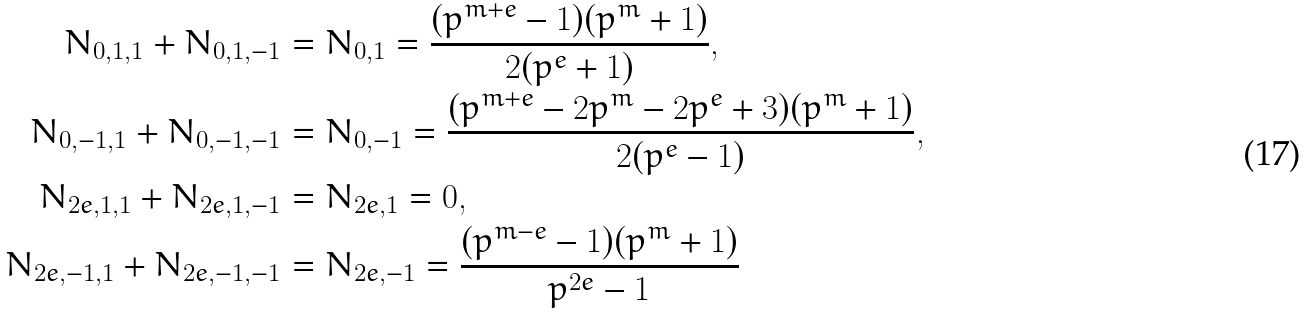<formula> <loc_0><loc_0><loc_500><loc_500>N _ { 0 , 1 , 1 } + N _ { 0 , 1 , - 1 } & = N _ { 0 , 1 } = \frac { ( p ^ { m + e } - 1 ) ( p ^ { m } + 1 ) } { 2 ( p ^ { e } + 1 ) } , \\ N _ { 0 , - 1 , 1 } + N _ { 0 , - 1 , - 1 } & = N _ { 0 , - 1 } = \frac { ( p ^ { m + e } - 2 p ^ { m } - 2 p ^ { e } + 3 ) ( p ^ { m } + 1 ) } { 2 ( p ^ { e } - 1 ) } , \\ N _ { 2 e , 1 , 1 } + N _ { 2 e , 1 , - 1 } & = N _ { 2 e , 1 } = 0 , \\ N _ { 2 e , - 1 , 1 } + N _ { 2 e , - 1 , - 1 } & = N _ { 2 e , - 1 } = \frac { ( p ^ { m - e } - 1 ) ( p ^ { m } + 1 ) } { p ^ { 2 e } - 1 }</formula> 